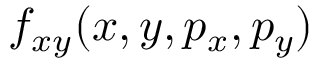Convert formula to latex. <formula><loc_0><loc_0><loc_500><loc_500>f _ { x y } ( x , y , p _ { x } , p _ { y } )</formula> 